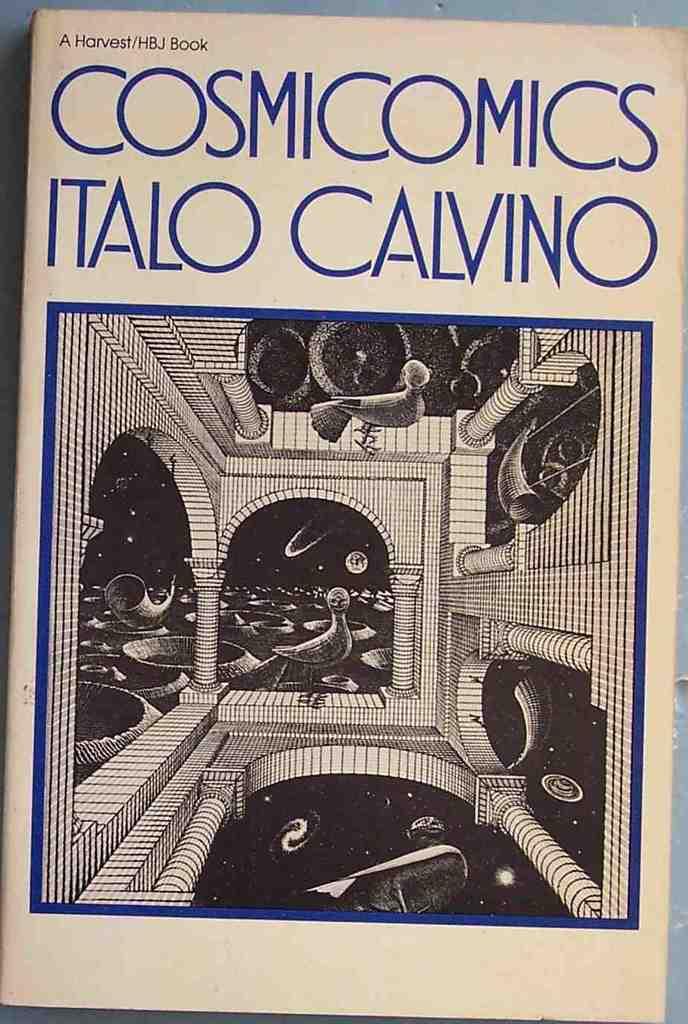What does it say in small black print on the top left?
Offer a very short reply. A harvest/hbj book. 